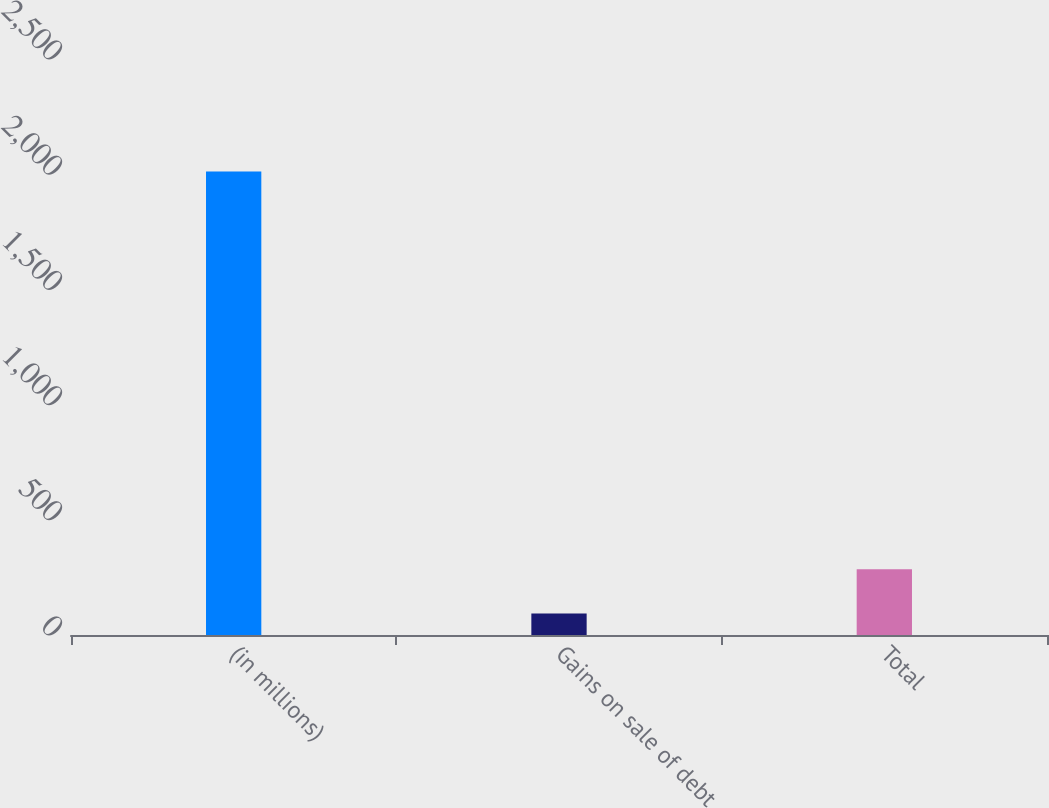Convert chart. <chart><loc_0><loc_0><loc_500><loc_500><bar_chart><fcel>(in millions)<fcel>Gains on sale of debt<fcel>Total<nl><fcel>2012<fcel>93<fcel>284.9<nl></chart> 